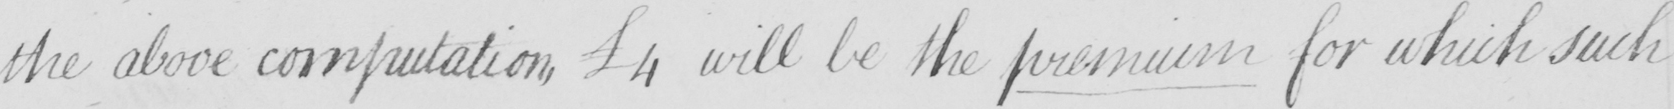Please provide the text content of this handwritten line. the above computation ,  £4 will be the premium for which such 